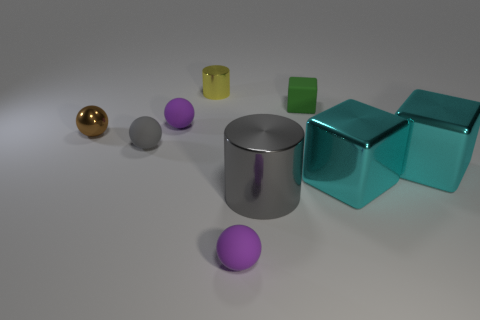What number of cylinders are in front of the green thing and behind the small gray matte ball?
Provide a short and direct response. 0. What number of other objects are the same shape as the small green matte thing?
Make the answer very short. 2. Is the number of small purple matte objects in front of the gray metal object greater than the number of tiny red rubber things?
Ensure brevity in your answer.  Yes. The metallic cylinder behind the large gray metal cylinder is what color?
Make the answer very short. Yellow. What size is the matte sphere that is the same color as the large cylinder?
Your answer should be very brief. Small. What number of shiny objects are either green things or large cyan blocks?
Make the answer very short. 2. There is a purple rubber sphere that is right of the cylinder to the left of the large cylinder; is there a purple matte object behind it?
Provide a short and direct response. Yes. There is a tiny metallic cylinder; how many tiny cylinders are behind it?
Provide a short and direct response. 0. There is a object that is the same color as the large cylinder; what is it made of?
Offer a terse response. Rubber. What number of large objects are yellow cylinders or green matte objects?
Offer a terse response. 0. 